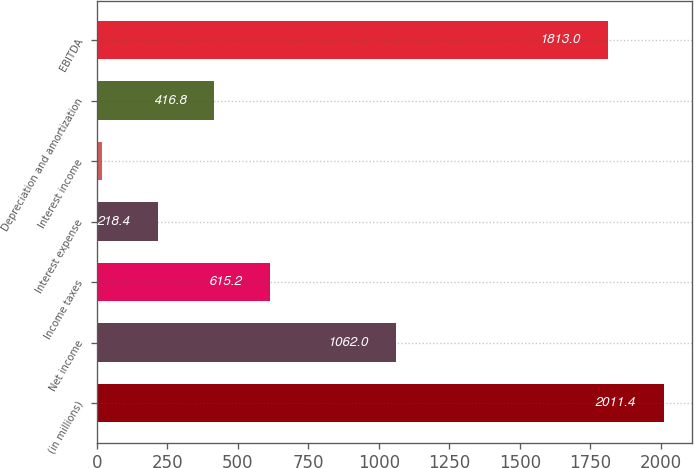Convert chart. <chart><loc_0><loc_0><loc_500><loc_500><bar_chart><fcel>(in millions)<fcel>Net income<fcel>Income taxes<fcel>Interest expense<fcel>Interest income<fcel>Depreciation and amortization<fcel>EBITDA<nl><fcel>2011.4<fcel>1062<fcel>615.2<fcel>218.4<fcel>20<fcel>416.8<fcel>1813<nl></chart> 